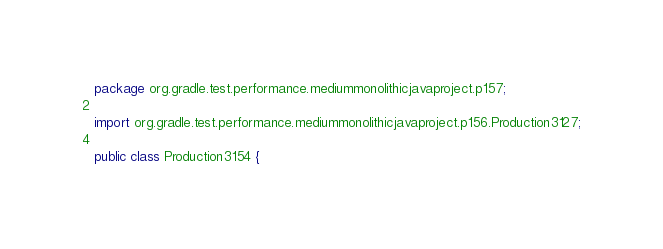<code> <loc_0><loc_0><loc_500><loc_500><_Java_>package org.gradle.test.performance.mediummonolithicjavaproject.p157;

import org.gradle.test.performance.mediummonolithicjavaproject.p156.Production3127;

public class Production3154 {        
</code> 